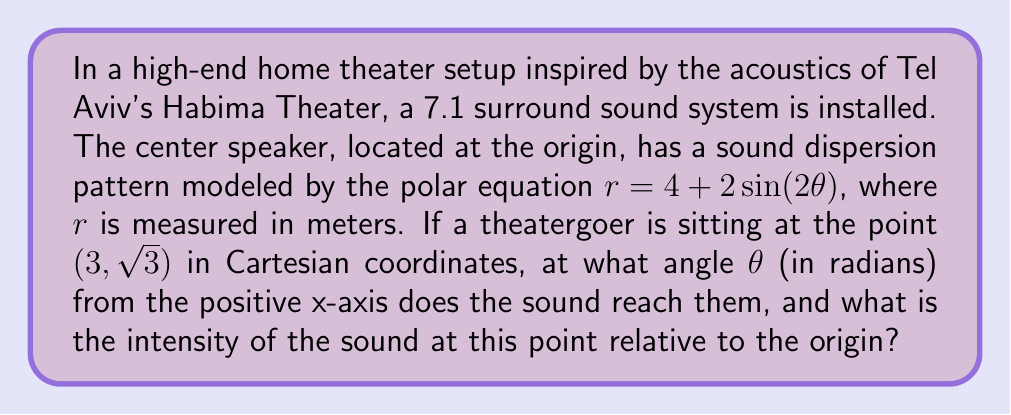Help me with this question. Let's approach this problem step-by-step:

1) First, we need to convert the given Cartesian coordinates $(3, \sqrt{3})$ to polar coordinates $(r, \theta)$.

2) To find $r$:
   $$r = \sqrt{x^2 + y^2} = \sqrt{3^2 + (\sqrt{3})^2} = \sqrt{9 + 3} = \sqrt{12} = 2\sqrt{3}$$

3) To find $\theta$:
   $$\theta = \tan^{-1}(\frac{y}{x}) = \tan^{-1}(\frac{\sqrt{3}}{3}) = \frac{\pi}{6}$$

4) Now we have the polar coordinates of the theatergoer: $(2\sqrt{3}, \frac{\pi}{6})$

5) To check if this point lies on the curve, we substitute these values into the equation:
   $$r = 4 + 2\sin(2\theta)$$
   $$2\sqrt{3} = 4 + 2\sin(2\cdot\frac{\pi}{6})$$
   $$2\sqrt{3} = 4 + 2\sin(\frac{\pi}{3}) = 4 + 2\cdot\frac{\sqrt{3}}{2} = 4 + \sqrt{3}$$

6) Since $2\sqrt{3} \approx 3.46$ and $4 + \sqrt{3} \approx 5.73$, the point does not lie exactly on the curve.

7) The intensity of sound typically decreases with the square of the distance. At the origin, $r = 4$ (when $\theta = 0$). At the theatergoer's position, $r = 2\sqrt{3}$. 

8) The relative intensity can be calculated as:
   $$\text{Relative Intensity} = (\frac{4}{2\sqrt{3}})^2 = \frac{16}{12} = \frac{4}{3}$$
Answer: The sound reaches the theatergoer at an angle of $\frac{\pi}{6}$ radians from the positive x-axis. The intensity of the sound at this point is $\frac{4}{3}$ times the intensity at the origin. 